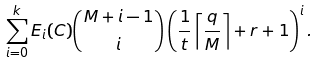<formula> <loc_0><loc_0><loc_500><loc_500>\sum _ { i = 0 } ^ { k } E _ { i } ( C ) { \binom { M + i - 1 } { i } } \left ( \frac { 1 } { t } \left \lceil \frac { q } { M } \right \rceil + r + 1 \right ) ^ { i } .</formula> 